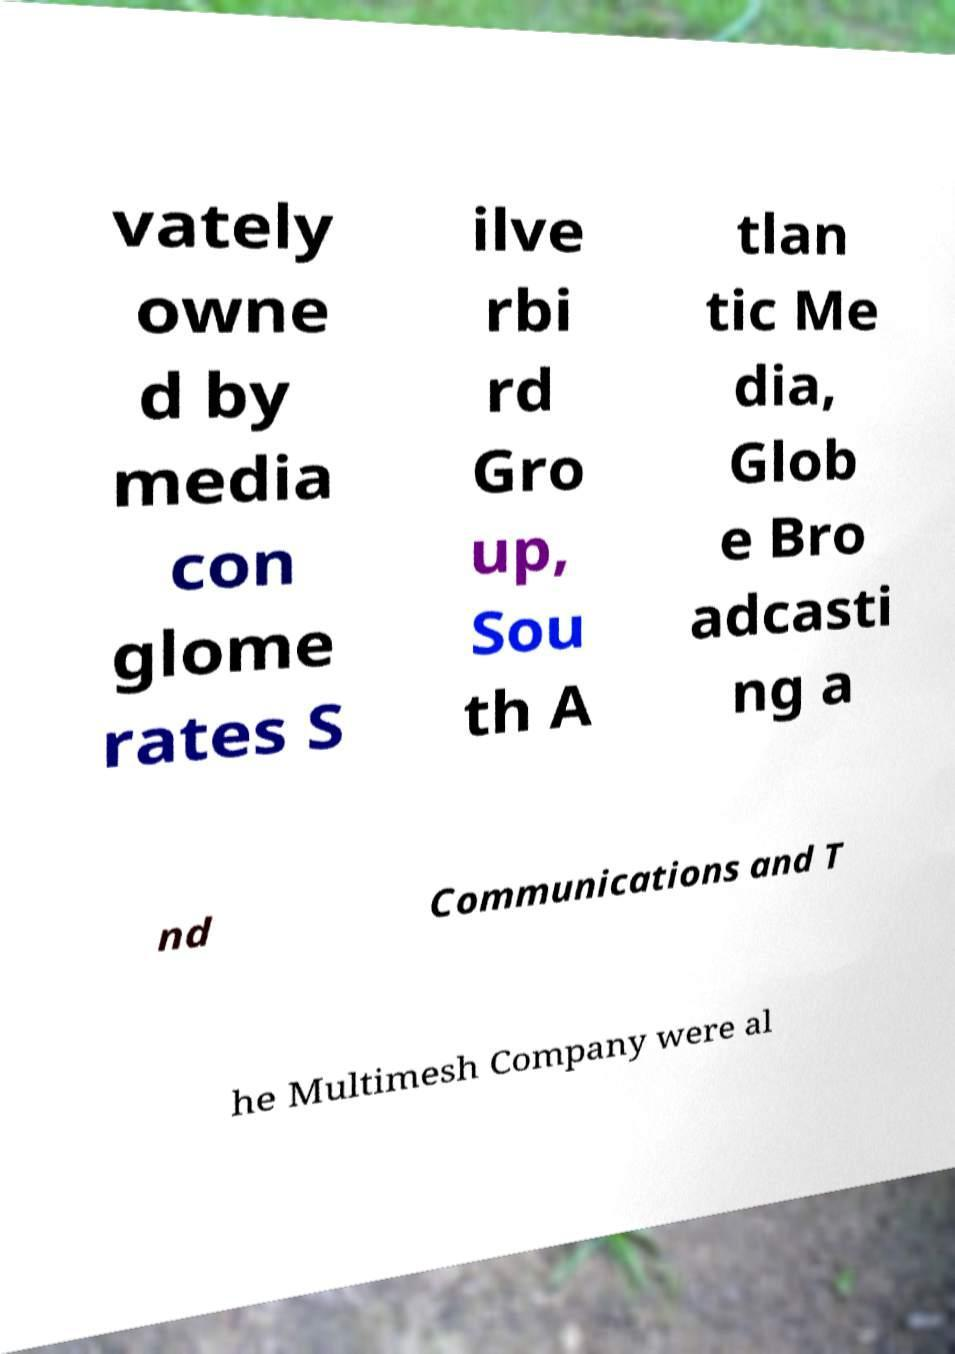For documentation purposes, I need the text within this image transcribed. Could you provide that? vately owne d by media con glome rates S ilve rbi rd Gro up, Sou th A tlan tic Me dia, Glob e Bro adcasti ng a nd Communications and T he Multimesh Company were al 